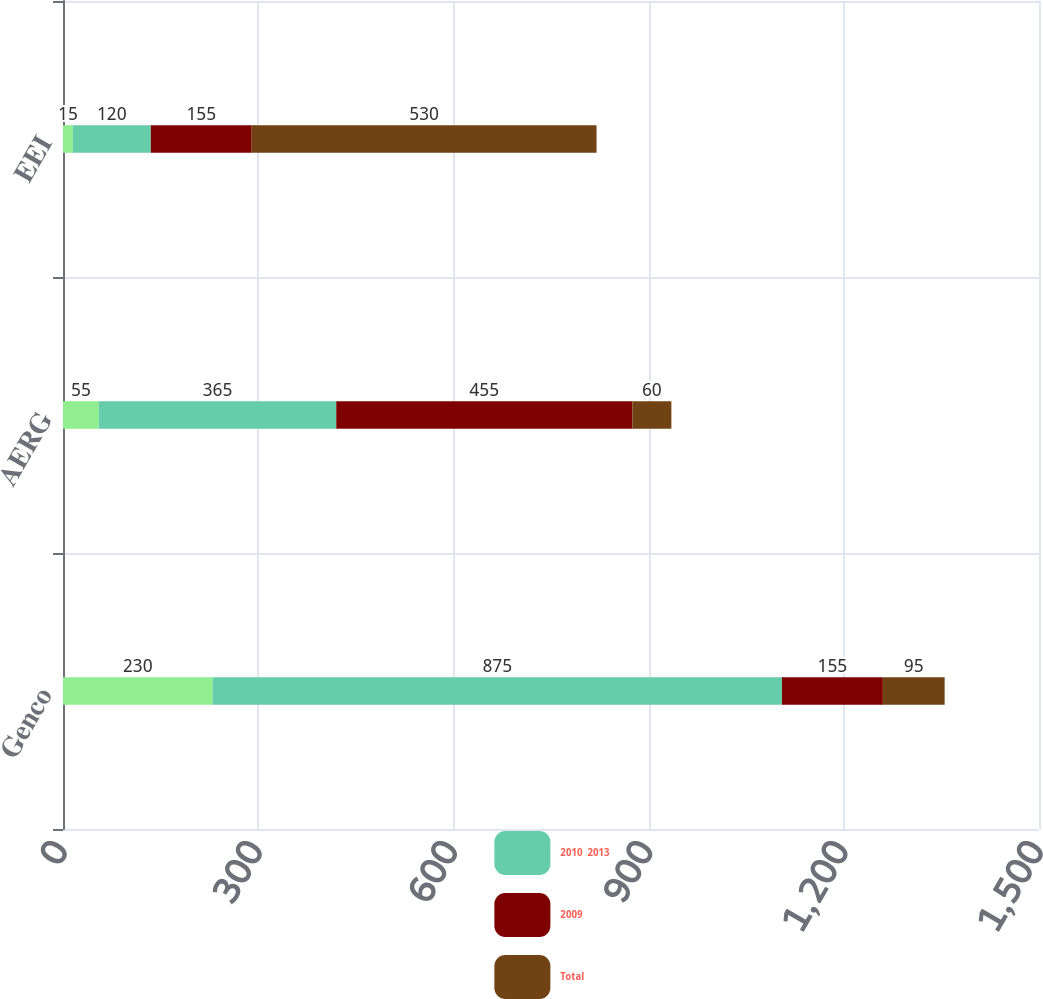Convert chart to OTSL. <chart><loc_0><loc_0><loc_500><loc_500><stacked_bar_chart><ecel><fcel>Genco<fcel>AERG<fcel>EEI<nl><fcel>nan<fcel>230<fcel>55<fcel>15<nl><fcel>2010  2013<fcel>875<fcel>365<fcel>120<nl><fcel>2009<fcel>155<fcel>455<fcel>155<nl><fcel>Total<fcel>95<fcel>60<fcel>530<nl></chart> 